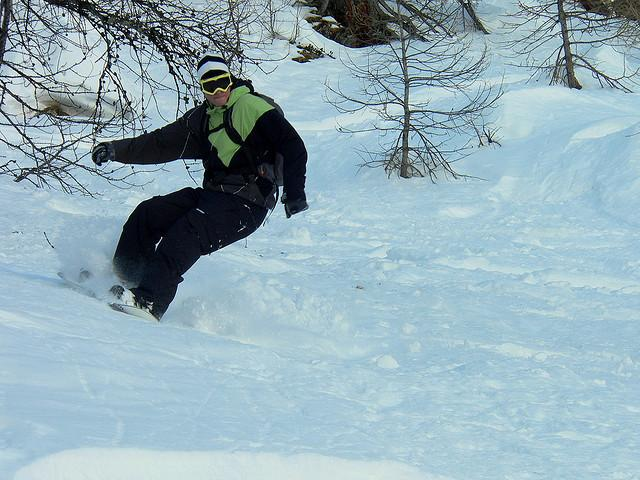What is the man wearing? Please explain your reasoning. goggles. He has the eye covering his eyes so he can see in the sun and does not get anything in his eyes. 